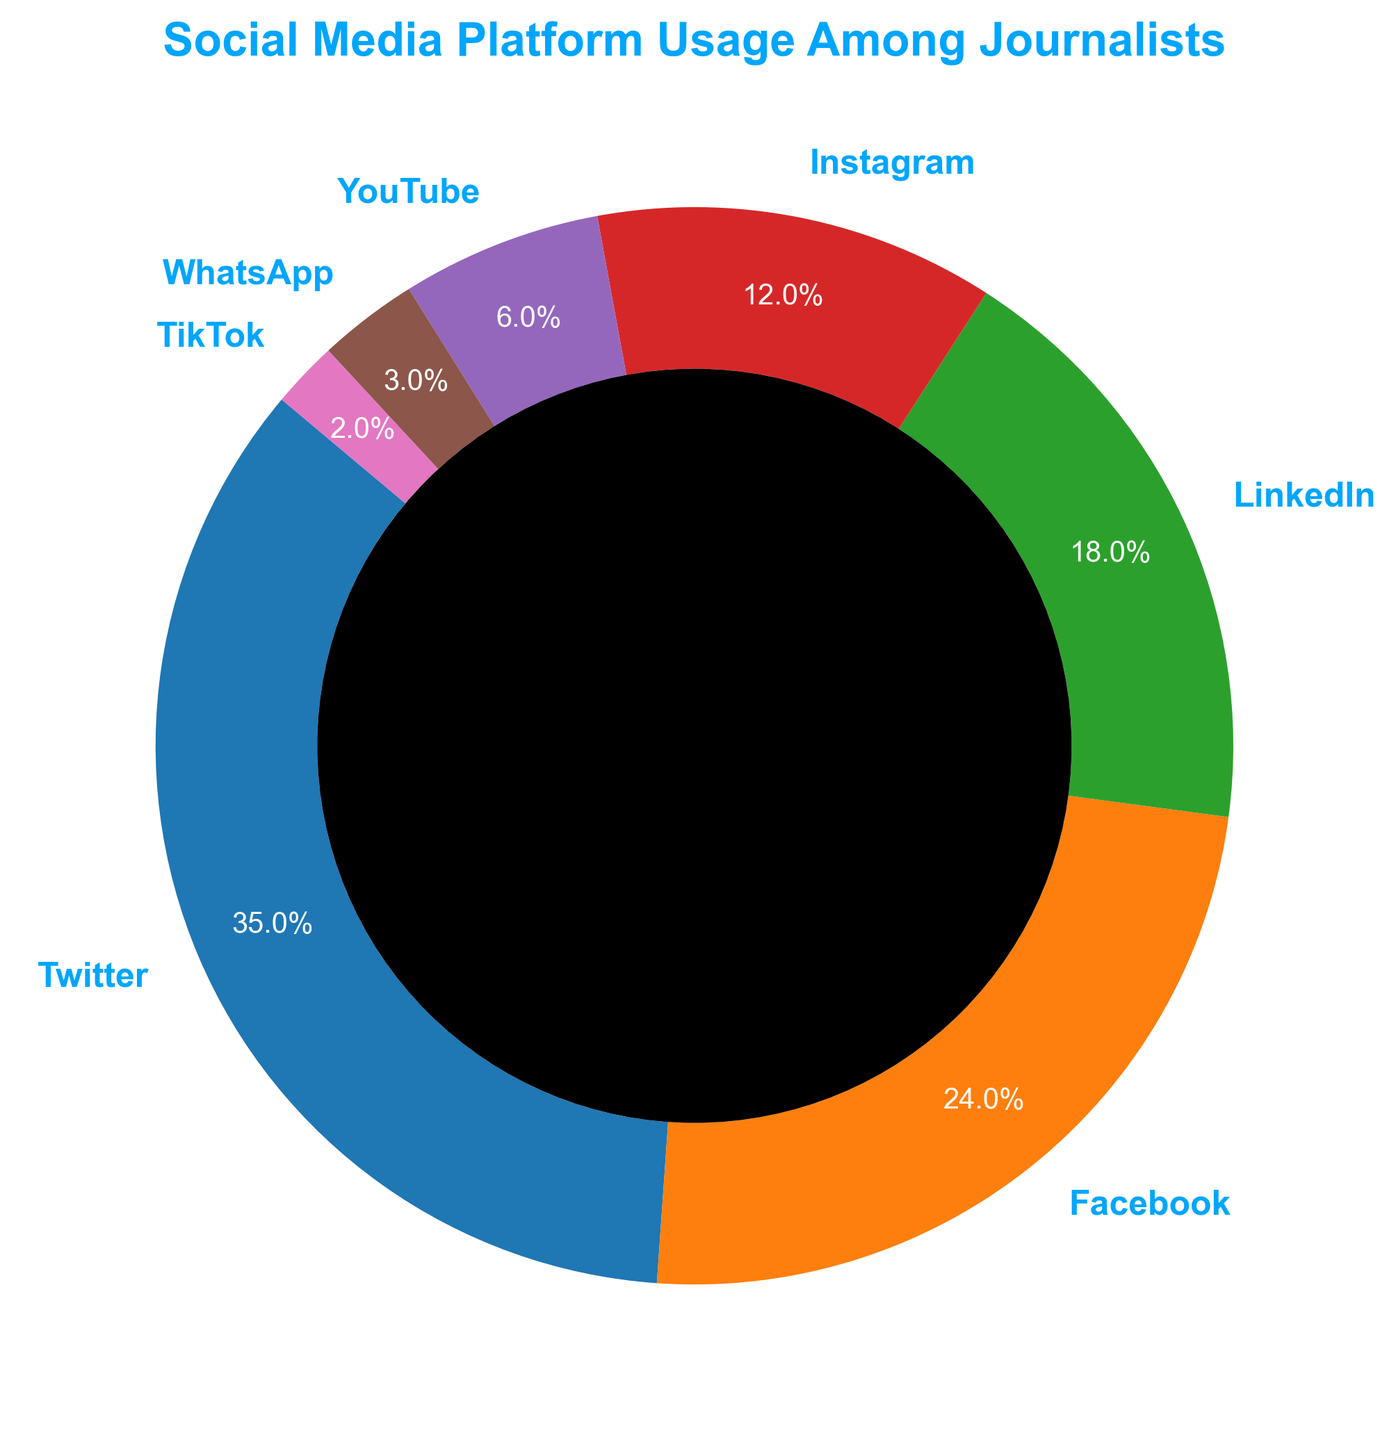What is the most used social media platform among journalists? The ring chart shows various social media platforms with their usage percentages among journalists. By identifying the platform that occupies the largest section of the ring, we can determine the most used platform. Here, it is Twitter with 35%.
Answer: Twitter What's the combined usage percentage of Instagram, YouTube, and TikTok among journalists? To find the combined usage percentage, add the usage percentages of Instagram (12%), YouTube (6%), and TikTok (2%). Summing these gives 12% + 6% + 2% = 20%.
Answer: 20% Which platform is used more by journalists, Facebook or LinkedIn, and by how much? By comparing the usage percentages of Facebook (24%) and LinkedIn (18%), we can see that Facebook is used more. The difference is 24% - 18% = 6%.
Answer: Facebook, by 6% What is the total usage percentage of platforms other than Twitter? First, exclude Twitter's usage percentage (35%) and sum up the rest: 24% + 18% + 12% + 6% + 3% + 2%. The sum is 65%.
Answer: 65% What's the least used social media platform among journalists? Observing the smallest section of the ring chart identifies the least used platform. TikTok has the smallest percentage at 2%.
Answer: TikTok What is the usage percentage gap between Instagram and YouTube? To find the difference between the usage percentages of Instagram (12%) and YouTube (6%), calculate 12% - 6% = 6%.
Answer: 6% Are Facebook and Instagram combined usage percentages more or less than Twitter? Summing the usage percentages of Facebook (24%) and Instagram (12%) gives 36%. Compare it with Twitter's 35%. 36% is greater than 35%.
Answer: More What's the average usage percentage of LinkedIn, YouTube, and WhatsApp? Calculate the average by adding the percentages of LinkedIn (18%), YouTube (6%), and WhatsApp (3%), then divide by 3: (18% + 6% + 3%) / 3 = 9%.
Answer: 9% Which platform has a usage percentage closest to 20%? The ring chart shows the usage percentages of each platform. The percentage closest to 20% is LinkedIn with 18%.
Answer: LinkedIn 